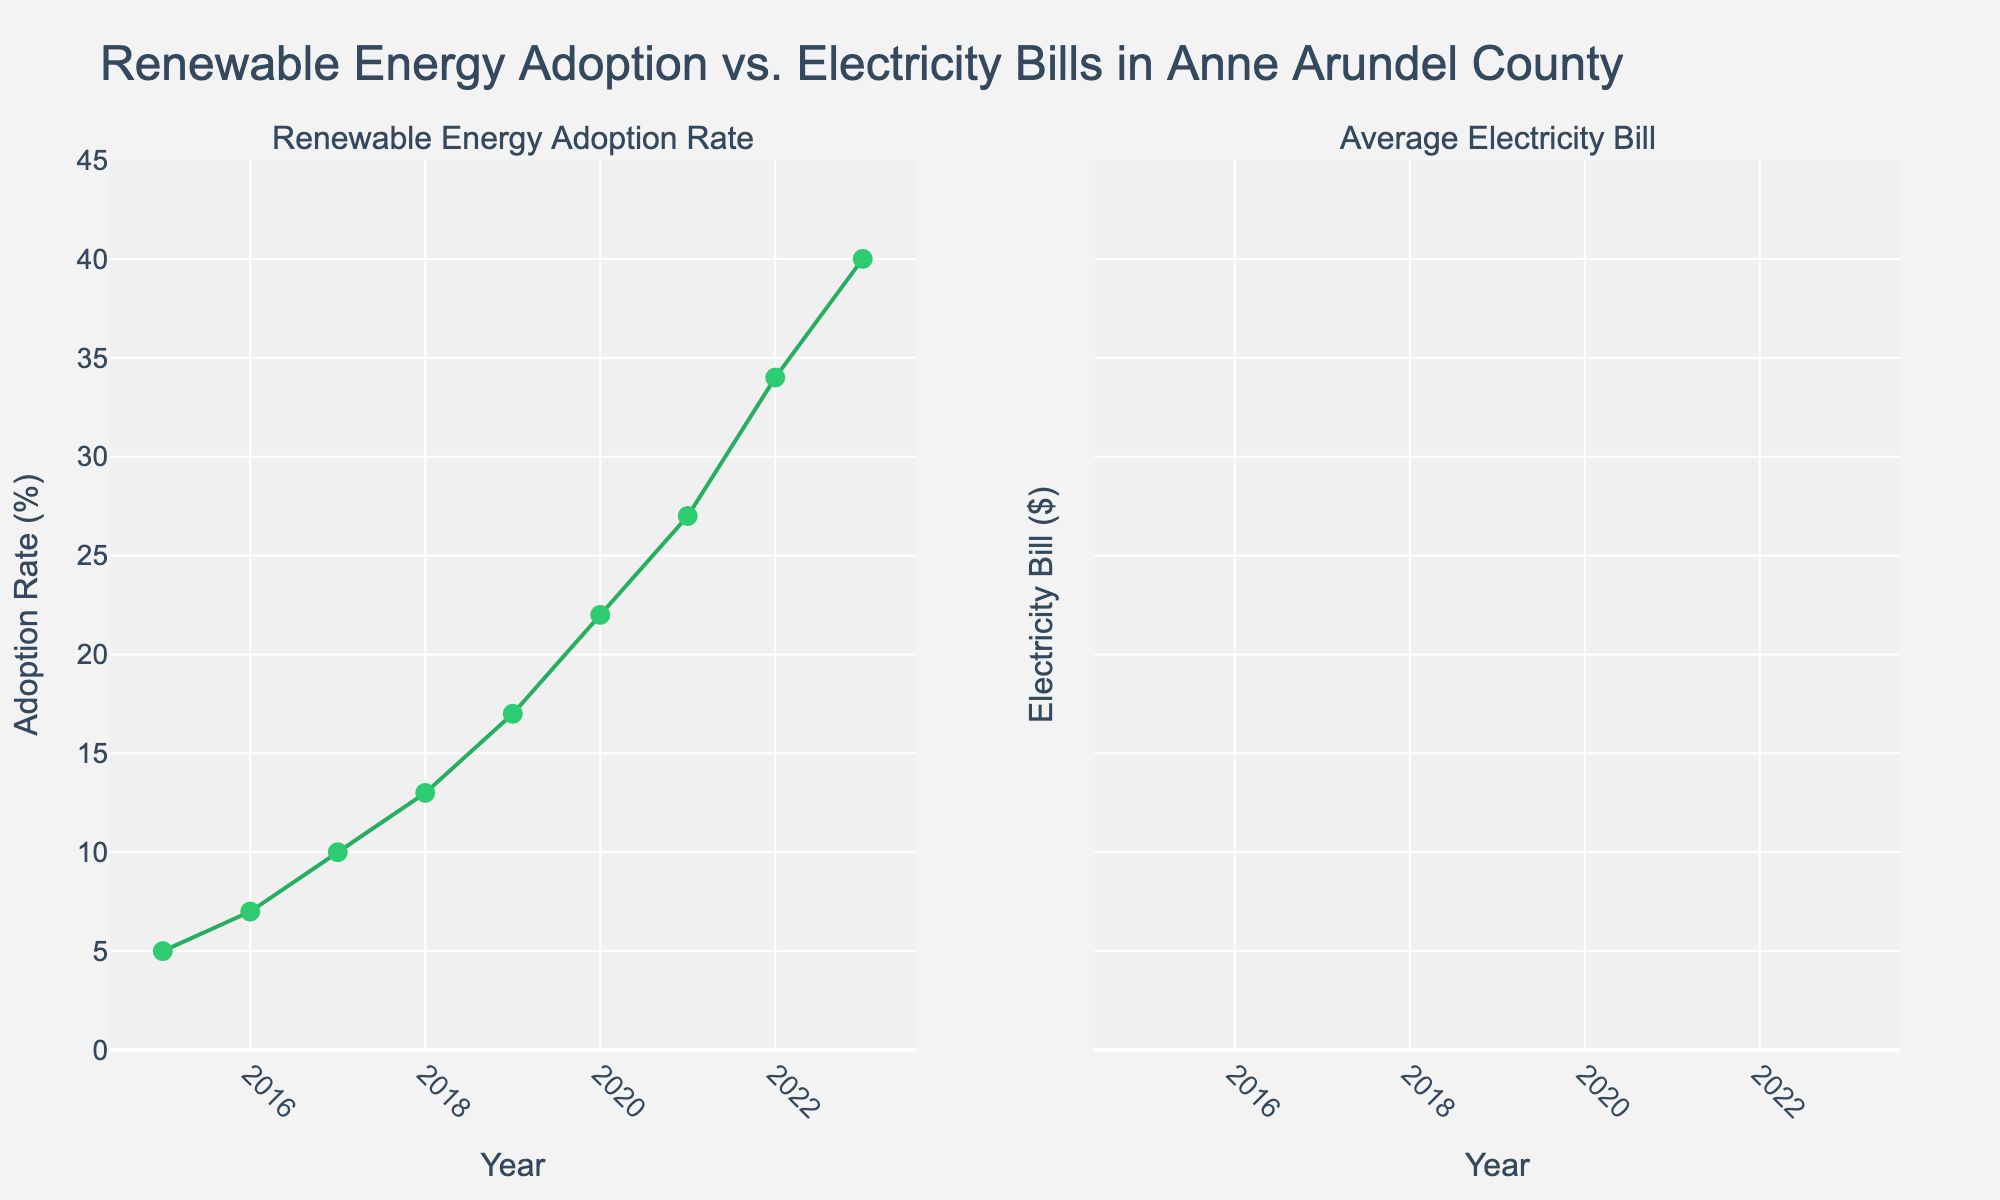What is the title of the plotted figure? The title is displayed at the top of the figure, indicating the content and focus of the plots.
Answer: Renewable Energy Adoption vs. Electricity Bills in Anne Arundel County How many subplots are there in the figure and what are they? The figure contains two subplots, each outlined in their section. The subplot titles describe their respective focus areas.
Answer: There are 2 subplots: "Renewable Energy Adoption Rate" and "Average Electricity Bill." What is the Renewable Energy Adoption Rate (%) in the year 2020? By looking at the first subplot, identify the data point corresponding to the year 2020 and read the Renewable Energy Adoption Rate (%) value.
Answer: 22% What is the color used for the markers representing the Adoption Rate in the first subplot? Observe the color of the markers specifically linked to the Adoption Rate, located on the left subplot.
Answer: Green Which year witnessed the highest increase in Renewable Energy Adoption Rate (%)? Identify the year with the largest difference between consecutive years’ Renewable Energy Adoption Rates in the first subplot.
Answer: 2022 By what amount has the Average Electricity Bill decreased from 2015 to 2023? Find the values of the Average Electricity Bills for 2015 and 2023 in the second subplot, then compute the decrease.
Answer: `$130 - $112 = $18` decrease Compare the Renewable Energy Adoption Rate in 2017 with the Average Electricity Bill in the same year. Which is higher? Look at the data points for 2017 in both subplots, compare the Renewable Energy Adoption Rate and the Average Electricity Bill values.
Answer: Average Electricity Bill ($126 is higher than 10%) In which year did the Renewable Energy Adoption Rate (%) first exceed 20%? Look at the first subplot and identify the first year where the Renewable Energy Adoption Rate passed the 20% mark.
Answer: 2020 What trend can you observe in the Average Electricity Bill from 2015 to 2023? Observe the progression of the data points in the second subplot over the years.
Answer: It shows a downward trend Between which years did the Renewable Energy Adoption Rate show a linear growth pattern? Evaluate the first subplot for sections where the rate of increase appears linear and identify the specific years.
Answer: 2018 to 2020 